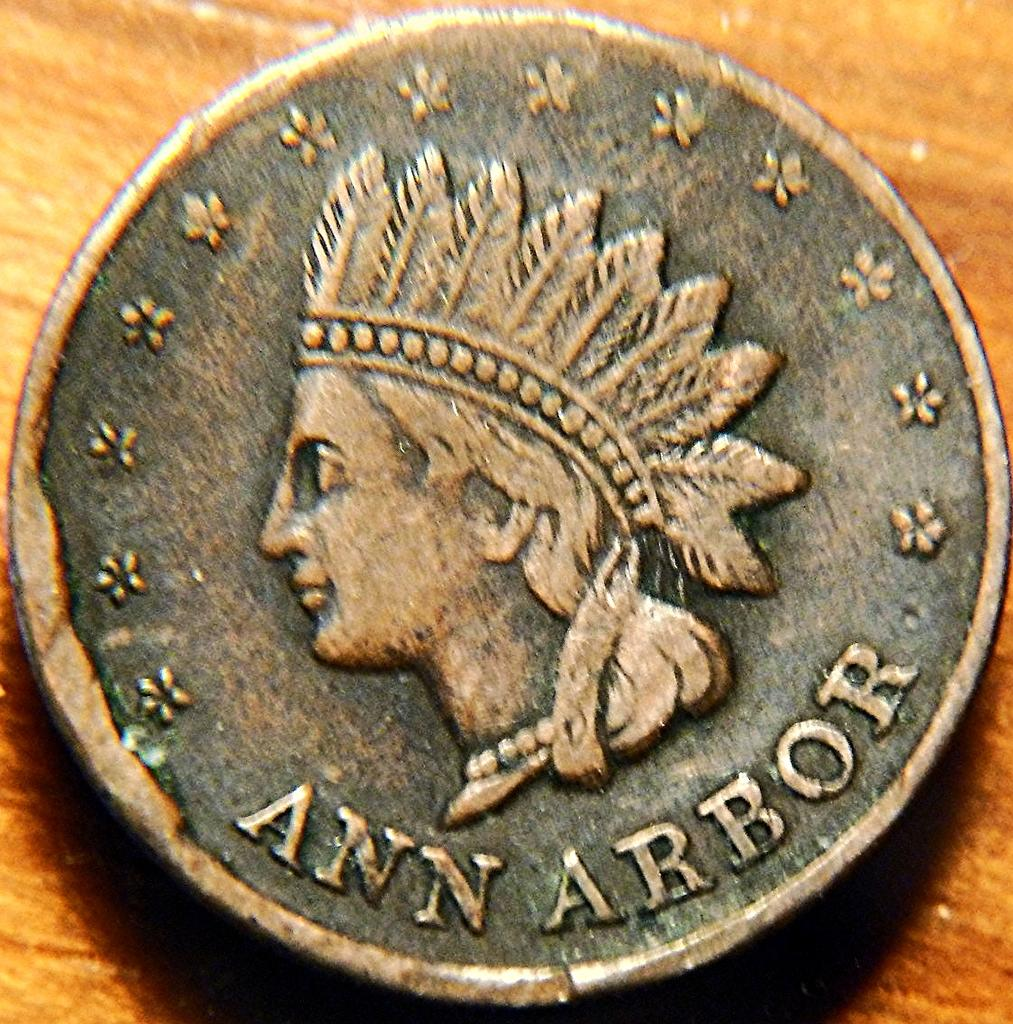What is the main subject of the image? The main subject of the image is a coin. Can you describe the design of the coin? The coin has a person depicted on it. Are there any words or letters on the coin? Yes, there is text on the coin. What type of bait is being used by the maid in the image? There is no maid or bait present in the image; it only features a coin with a person depicted on it and text. 